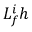<formula> <loc_0><loc_0><loc_500><loc_500>L _ { f } ^ { i } h</formula> 